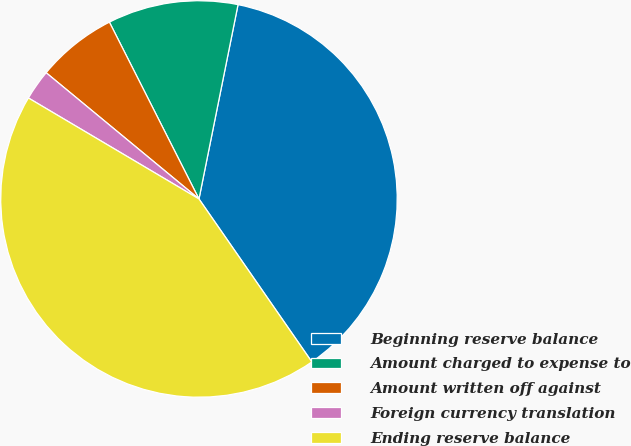Convert chart. <chart><loc_0><loc_0><loc_500><loc_500><pie_chart><fcel>Beginning reserve balance<fcel>Amount charged to expense to<fcel>Amount written off against<fcel>Foreign currency translation<fcel>Ending reserve balance<nl><fcel>37.2%<fcel>10.62%<fcel>6.55%<fcel>2.48%<fcel>43.15%<nl></chart> 